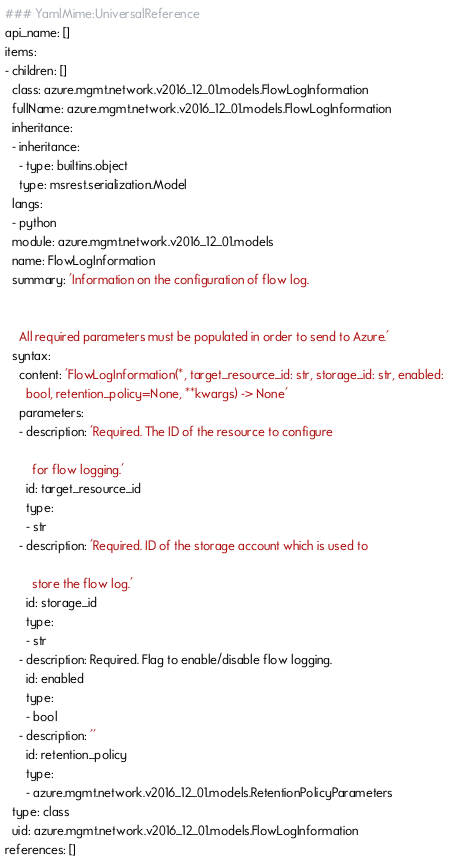<code> <loc_0><loc_0><loc_500><loc_500><_YAML_>### YamlMime:UniversalReference
api_name: []
items:
- children: []
  class: azure.mgmt.network.v2016_12_01.models.FlowLogInformation
  fullName: azure.mgmt.network.v2016_12_01.models.FlowLogInformation
  inheritance:
  - inheritance:
    - type: builtins.object
    type: msrest.serialization.Model
  langs:
  - python
  module: azure.mgmt.network.v2016_12_01.models
  name: FlowLogInformation
  summary: 'Information on the configuration of flow log.


    All required parameters must be populated in order to send to Azure.'
  syntax:
    content: 'FlowLogInformation(*, target_resource_id: str, storage_id: str, enabled:
      bool, retention_policy=None, **kwargs) -> None'
    parameters:
    - description: 'Required. The ID of the resource to configure

        for flow logging.'
      id: target_resource_id
      type:
      - str
    - description: 'Required. ID of the storage account which is used to

        store the flow log.'
      id: storage_id
      type:
      - str
    - description: Required. Flag to enable/disable flow logging.
      id: enabled
      type:
      - bool
    - description: ''
      id: retention_policy
      type:
      - azure.mgmt.network.v2016_12_01.models.RetentionPolicyParameters
  type: class
  uid: azure.mgmt.network.v2016_12_01.models.FlowLogInformation
references: []
</code> 